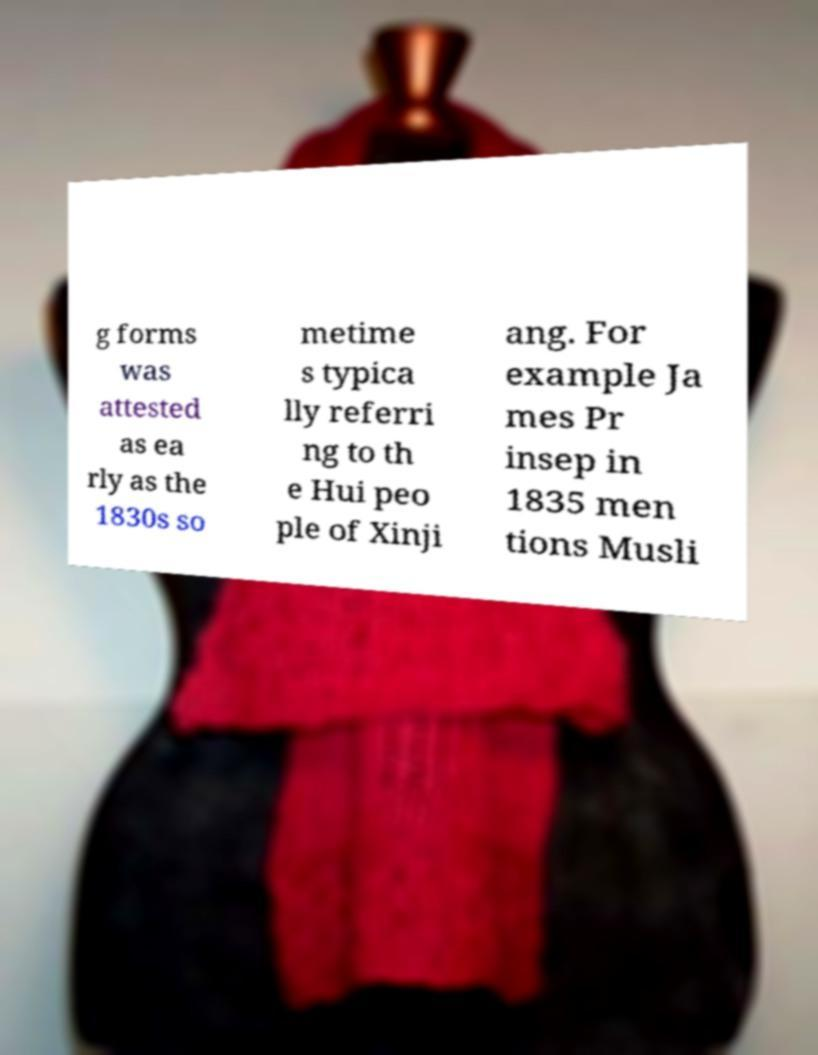There's text embedded in this image that I need extracted. Can you transcribe it verbatim? g forms was attested as ea rly as the 1830s so metime s typica lly referri ng to th e Hui peo ple of Xinji ang. For example Ja mes Pr insep in 1835 men tions Musli 